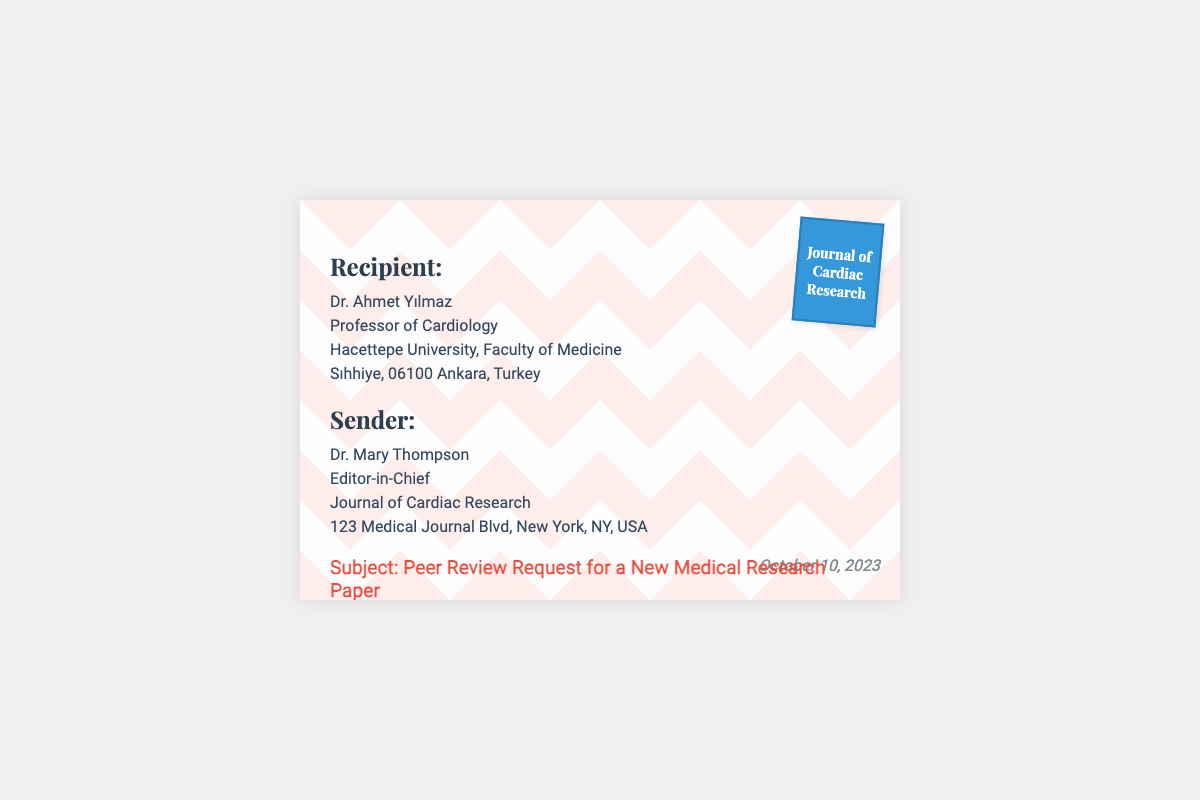What is the recipient's name? The recipient's name is listed prominently in the document as part of the greeting section.
Answer: Dr. Ahmet Yılmaz What is the profession of the recipient? The profession of the recipient is mentioned directly under their name.
Answer: Professor of Cardiology What institution does the recipient belong to? The institution is given immediately following the recipient's profession.
Answer: Hacettepe University, Faculty of Medicine What is the subject of the letter? The subject is clearly stated in the envelope content, indicating the purpose of the request.
Answer: Peer Review Request for a New Medical Research Paper Who is the sender of the envelope? The sender's name is indicated in the sender section of the document.
Answer: Dr. Mary Thompson What is the date of the document? The date is provided at the bottom of the envelope, specifying when the request was sent.
Answer: October 10, 2023 Which journal is associated with the sender? The journal name is mentioned both in the sender section and on the stamp.
Answer: Journal of Cardiac Research What city is the sender located in? The city is given in the sender's address within the document.
Answer: New York What is the purpose of the envelope? The purpose is encapsulated in the subject line, explaining the nature of the correspondence.
Answer: Peer review request 